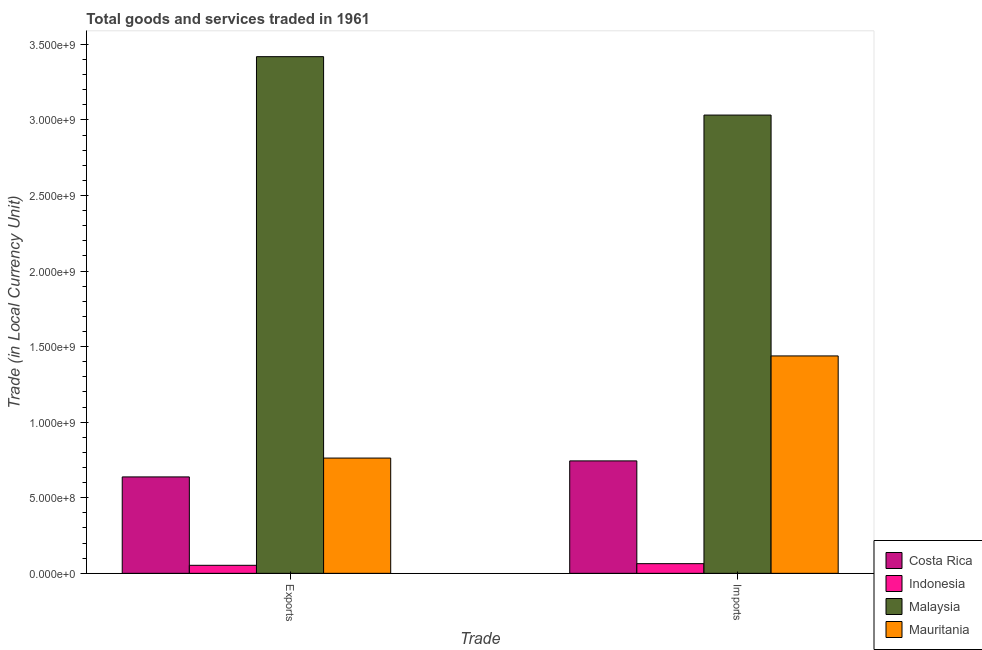How many different coloured bars are there?
Provide a succinct answer. 4. How many groups of bars are there?
Your response must be concise. 2. Are the number of bars per tick equal to the number of legend labels?
Your answer should be very brief. Yes. Are the number of bars on each tick of the X-axis equal?
Your answer should be compact. Yes. How many bars are there on the 1st tick from the left?
Your answer should be compact. 4. What is the label of the 1st group of bars from the left?
Your answer should be compact. Exports. What is the imports of goods and services in Mauritania?
Offer a very short reply. 1.44e+09. Across all countries, what is the maximum imports of goods and services?
Your answer should be very brief. 3.03e+09. Across all countries, what is the minimum imports of goods and services?
Give a very brief answer. 6.40e+07. In which country was the imports of goods and services maximum?
Your answer should be very brief. Malaysia. In which country was the export of goods and services minimum?
Your answer should be very brief. Indonesia. What is the total export of goods and services in the graph?
Provide a succinct answer. 4.87e+09. What is the difference between the export of goods and services in Costa Rica and that in Mauritania?
Ensure brevity in your answer.  -1.25e+08. What is the difference between the imports of goods and services in Indonesia and the export of goods and services in Costa Rica?
Offer a terse response. -5.74e+08. What is the average imports of goods and services per country?
Offer a terse response. 1.32e+09. What is the difference between the export of goods and services and imports of goods and services in Indonesia?
Your response must be concise. -1.09e+07. What is the ratio of the export of goods and services in Indonesia to that in Mauritania?
Provide a succinct answer. 0.07. In how many countries, is the imports of goods and services greater than the average imports of goods and services taken over all countries?
Keep it short and to the point. 2. What does the 3rd bar from the left in Exports represents?
Provide a succinct answer. Malaysia. What does the 4th bar from the right in Exports represents?
Offer a very short reply. Costa Rica. How many bars are there?
Your response must be concise. 8. How many countries are there in the graph?
Offer a very short reply. 4. Are the values on the major ticks of Y-axis written in scientific E-notation?
Your response must be concise. Yes. Does the graph contain grids?
Keep it short and to the point. No. Where does the legend appear in the graph?
Provide a short and direct response. Bottom right. What is the title of the graph?
Keep it short and to the point. Total goods and services traded in 1961. Does "Niger" appear as one of the legend labels in the graph?
Give a very brief answer. No. What is the label or title of the X-axis?
Provide a short and direct response. Trade. What is the label or title of the Y-axis?
Your answer should be very brief. Trade (in Local Currency Unit). What is the Trade (in Local Currency Unit) of Costa Rica in Exports?
Offer a very short reply. 6.38e+08. What is the Trade (in Local Currency Unit) of Indonesia in Exports?
Offer a very short reply. 5.31e+07. What is the Trade (in Local Currency Unit) of Malaysia in Exports?
Provide a succinct answer. 3.42e+09. What is the Trade (in Local Currency Unit) in Mauritania in Exports?
Keep it short and to the point. 7.63e+08. What is the Trade (in Local Currency Unit) of Costa Rica in Imports?
Give a very brief answer. 7.44e+08. What is the Trade (in Local Currency Unit) of Indonesia in Imports?
Your response must be concise. 6.40e+07. What is the Trade (in Local Currency Unit) in Malaysia in Imports?
Your response must be concise. 3.03e+09. What is the Trade (in Local Currency Unit) in Mauritania in Imports?
Provide a short and direct response. 1.44e+09. Across all Trade, what is the maximum Trade (in Local Currency Unit) of Costa Rica?
Give a very brief answer. 7.44e+08. Across all Trade, what is the maximum Trade (in Local Currency Unit) in Indonesia?
Your answer should be compact. 6.40e+07. Across all Trade, what is the maximum Trade (in Local Currency Unit) of Malaysia?
Provide a short and direct response. 3.42e+09. Across all Trade, what is the maximum Trade (in Local Currency Unit) of Mauritania?
Make the answer very short. 1.44e+09. Across all Trade, what is the minimum Trade (in Local Currency Unit) in Costa Rica?
Your answer should be compact. 6.38e+08. Across all Trade, what is the minimum Trade (in Local Currency Unit) of Indonesia?
Make the answer very short. 5.31e+07. Across all Trade, what is the minimum Trade (in Local Currency Unit) of Malaysia?
Provide a short and direct response. 3.03e+09. Across all Trade, what is the minimum Trade (in Local Currency Unit) in Mauritania?
Your response must be concise. 7.63e+08. What is the total Trade (in Local Currency Unit) of Costa Rica in the graph?
Your answer should be compact. 1.38e+09. What is the total Trade (in Local Currency Unit) in Indonesia in the graph?
Give a very brief answer. 1.17e+08. What is the total Trade (in Local Currency Unit) in Malaysia in the graph?
Provide a succinct answer. 6.45e+09. What is the total Trade (in Local Currency Unit) of Mauritania in the graph?
Provide a short and direct response. 2.20e+09. What is the difference between the Trade (in Local Currency Unit) of Costa Rica in Exports and that in Imports?
Keep it short and to the point. -1.06e+08. What is the difference between the Trade (in Local Currency Unit) in Indonesia in Exports and that in Imports?
Give a very brief answer. -1.09e+07. What is the difference between the Trade (in Local Currency Unit) of Malaysia in Exports and that in Imports?
Keep it short and to the point. 3.87e+08. What is the difference between the Trade (in Local Currency Unit) in Mauritania in Exports and that in Imports?
Provide a short and direct response. -6.76e+08. What is the difference between the Trade (in Local Currency Unit) of Costa Rica in Exports and the Trade (in Local Currency Unit) of Indonesia in Imports?
Your answer should be compact. 5.74e+08. What is the difference between the Trade (in Local Currency Unit) in Costa Rica in Exports and the Trade (in Local Currency Unit) in Malaysia in Imports?
Give a very brief answer. -2.39e+09. What is the difference between the Trade (in Local Currency Unit) in Costa Rica in Exports and the Trade (in Local Currency Unit) in Mauritania in Imports?
Offer a terse response. -8.00e+08. What is the difference between the Trade (in Local Currency Unit) of Indonesia in Exports and the Trade (in Local Currency Unit) of Malaysia in Imports?
Your answer should be compact. -2.98e+09. What is the difference between the Trade (in Local Currency Unit) of Indonesia in Exports and the Trade (in Local Currency Unit) of Mauritania in Imports?
Keep it short and to the point. -1.39e+09. What is the difference between the Trade (in Local Currency Unit) in Malaysia in Exports and the Trade (in Local Currency Unit) in Mauritania in Imports?
Your answer should be very brief. 1.98e+09. What is the average Trade (in Local Currency Unit) in Costa Rica per Trade?
Give a very brief answer. 6.91e+08. What is the average Trade (in Local Currency Unit) in Indonesia per Trade?
Offer a terse response. 5.86e+07. What is the average Trade (in Local Currency Unit) of Malaysia per Trade?
Give a very brief answer. 3.23e+09. What is the average Trade (in Local Currency Unit) in Mauritania per Trade?
Offer a very short reply. 1.10e+09. What is the difference between the Trade (in Local Currency Unit) in Costa Rica and Trade (in Local Currency Unit) in Indonesia in Exports?
Provide a succinct answer. 5.85e+08. What is the difference between the Trade (in Local Currency Unit) in Costa Rica and Trade (in Local Currency Unit) in Malaysia in Exports?
Make the answer very short. -2.78e+09. What is the difference between the Trade (in Local Currency Unit) in Costa Rica and Trade (in Local Currency Unit) in Mauritania in Exports?
Your answer should be compact. -1.25e+08. What is the difference between the Trade (in Local Currency Unit) of Indonesia and Trade (in Local Currency Unit) of Malaysia in Exports?
Your answer should be compact. -3.37e+09. What is the difference between the Trade (in Local Currency Unit) of Indonesia and Trade (in Local Currency Unit) of Mauritania in Exports?
Make the answer very short. -7.10e+08. What is the difference between the Trade (in Local Currency Unit) in Malaysia and Trade (in Local Currency Unit) in Mauritania in Exports?
Provide a succinct answer. 2.66e+09. What is the difference between the Trade (in Local Currency Unit) in Costa Rica and Trade (in Local Currency Unit) in Indonesia in Imports?
Your answer should be compact. 6.80e+08. What is the difference between the Trade (in Local Currency Unit) of Costa Rica and Trade (in Local Currency Unit) of Malaysia in Imports?
Offer a very short reply. -2.29e+09. What is the difference between the Trade (in Local Currency Unit) of Costa Rica and Trade (in Local Currency Unit) of Mauritania in Imports?
Your answer should be compact. -6.94e+08. What is the difference between the Trade (in Local Currency Unit) of Indonesia and Trade (in Local Currency Unit) of Malaysia in Imports?
Your answer should be compact. -2.97e+09. What is the difference between the Trade (in Local Currency Unit) in Indonesia and Trade (in Local Currency Unit) in Mauritania in Imports?
Your answer should be compact. -1.37e+09. What is the difference between the Trade (in Local Currency Unit) in Malaysia and Trade (in Local Currency Unit) in Mauritania in Imports?
Offer a very short reply. 1.59e+09. What is the ratio of the Trade (in Local Currency Unit) of Costa Rica in Exports to that in Imports?
Make the answer very short. 0.86. What is the ratio of the Trade (in Local Currency Unit) in Indonesia in Exports to that in Imports?
Give a very brief answer. 0.83. What is the ratio of the Trade (in Local Currency Unit) in Malaysia in Exports to that in Imports?
Your response must be concise. 1.13. What is the ratio of the Trade (in Local Currency Unit) in Mauritania in Exports to that in Imports?
Provide a short and direct response. 0.53. What is the difference between the highest and the second highest Trade (in Local Currency Unit) in Costa Rica?
Your response must be concise. 1.06e+08. What is the difference between the highest and the second highest Trade (in Local Currency Unit) of Indonesia?
Give a very brief answer. 1.09e+07. What is the difference between the highest and the second highest Trade (in Local Currency Unit) of Malaysia?
Offer a terse response. 3.87e+08. What is the difference between the highest and the second highest Trade (in Local Currency Unit) of Mauritania?
Provide a succinct answer. 6.76e+08. What is the difference between the highest and the lowest Trade (in Local Currency Unit) of Costa Rica?
Your answer should be very brief. 1.06e+08. What is the difference between the highest and the lowest Trade (in Local Currency Unit) in Indonesia?
Your answer should be very brief. 1.09e+07. What is the difference between the highest and the lowest Trade (in Local Currency Unit) in Malaysia?
Keep it short and to the point. 3.87e+08. What is the difference between the highest and the lowest Trade (in Local Currency Unit) of Mauritania?
Your answer should be compact. 6.76e+08. 